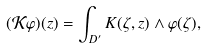<formula> <loc_0><loc_0><loc_500><loc_500>( \mathcal { K } \varphi ) ( z ) = \int _ { D ^ { \prime } } K ( \zeta , z ) \wedge \varphi ( \zeta ) ,</formula> 